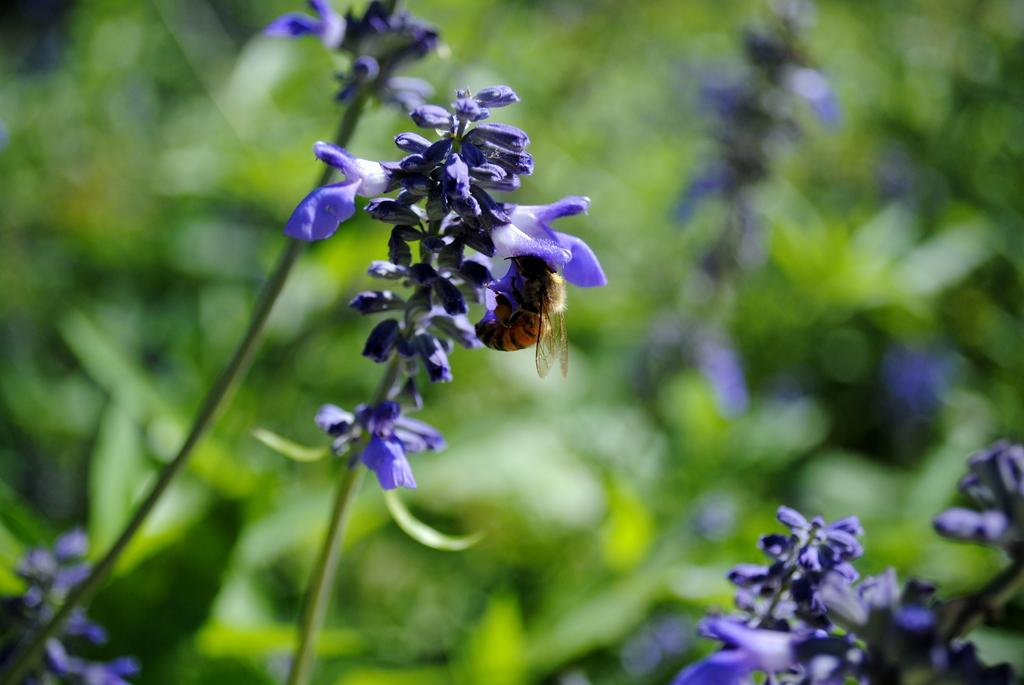What types of living organisms can be seen in the image? Plants and flowers are visible in the image. Is there any interaction between the plants and animals in the image? Yes, there is an insect on a flower in the image. How would you describe the background of the image? The background of the image is blurred. What type of memory is being used by the plants in the image? There is no indication in the image that the plants are using any type of memory. Can you see a ball in the image? There is no ball present in the image. 